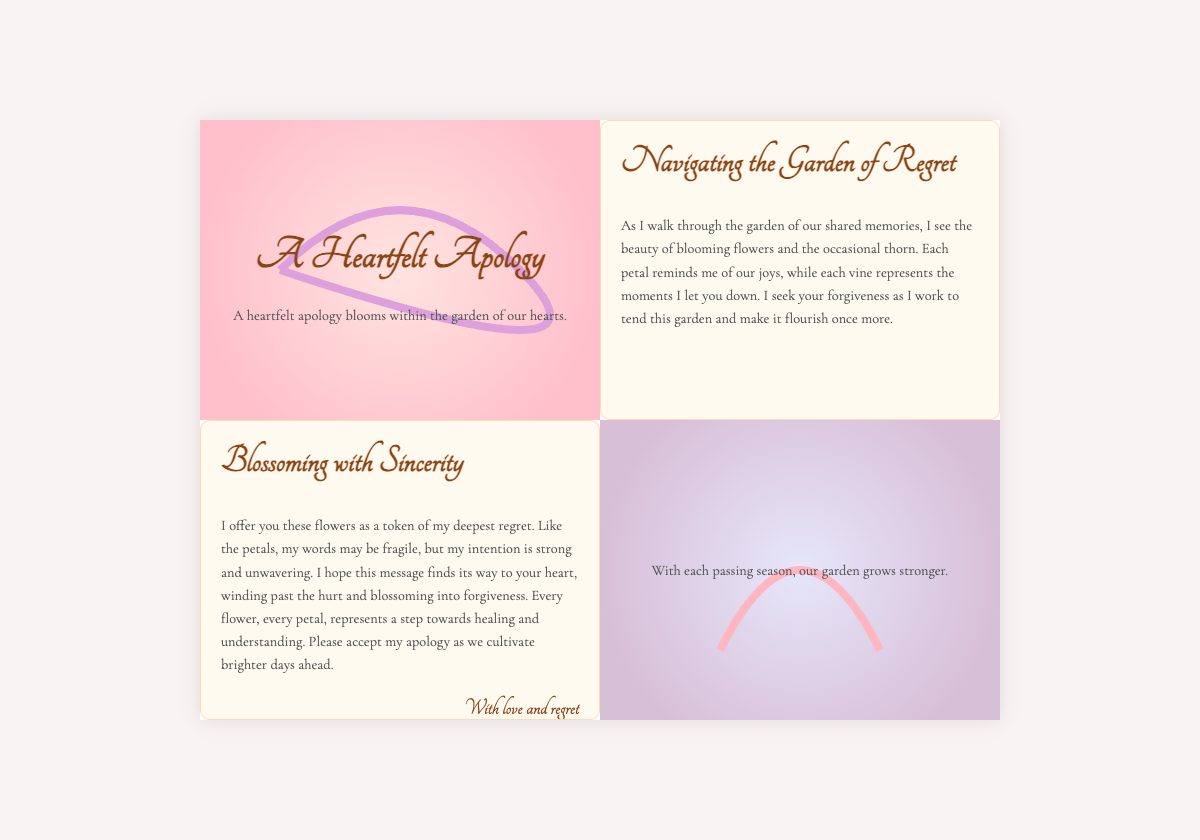what is the title of the card? The title of the card is displayed prominently at the top of the cover section.
Answer: A Heartfelt Apology who is the message intended for? The message is directed to someone for whom an apology is being expressed.
Answer: You what is the main metaphor used throughout the card? The card uses the metaphor of a garden to symbolize the relationship and the apology.
Answer: Garden how are flowers described in the context of the apology? Flowers are used as a symbol of regret and sincerity in the apology message.
Answer: Token of regret what does the phrase "blossoming into forgiveness" suggest? This phrase suggests a hopeful transformation of the relationship towards reconciliation and healing.
Answer: Hopeful transformation how many sections does the card have? The card layout consists of several sections that convey different messages and emotions.
Answer: Four what colors dominate the card's design? The card features soft pastel colors primarily associated with petals and vines.
Answer: Pastels what is the closing sentiment of the card? The closing sentiment of the card expresses love and an acknowledgment of regret.
Answer: With love and regret 